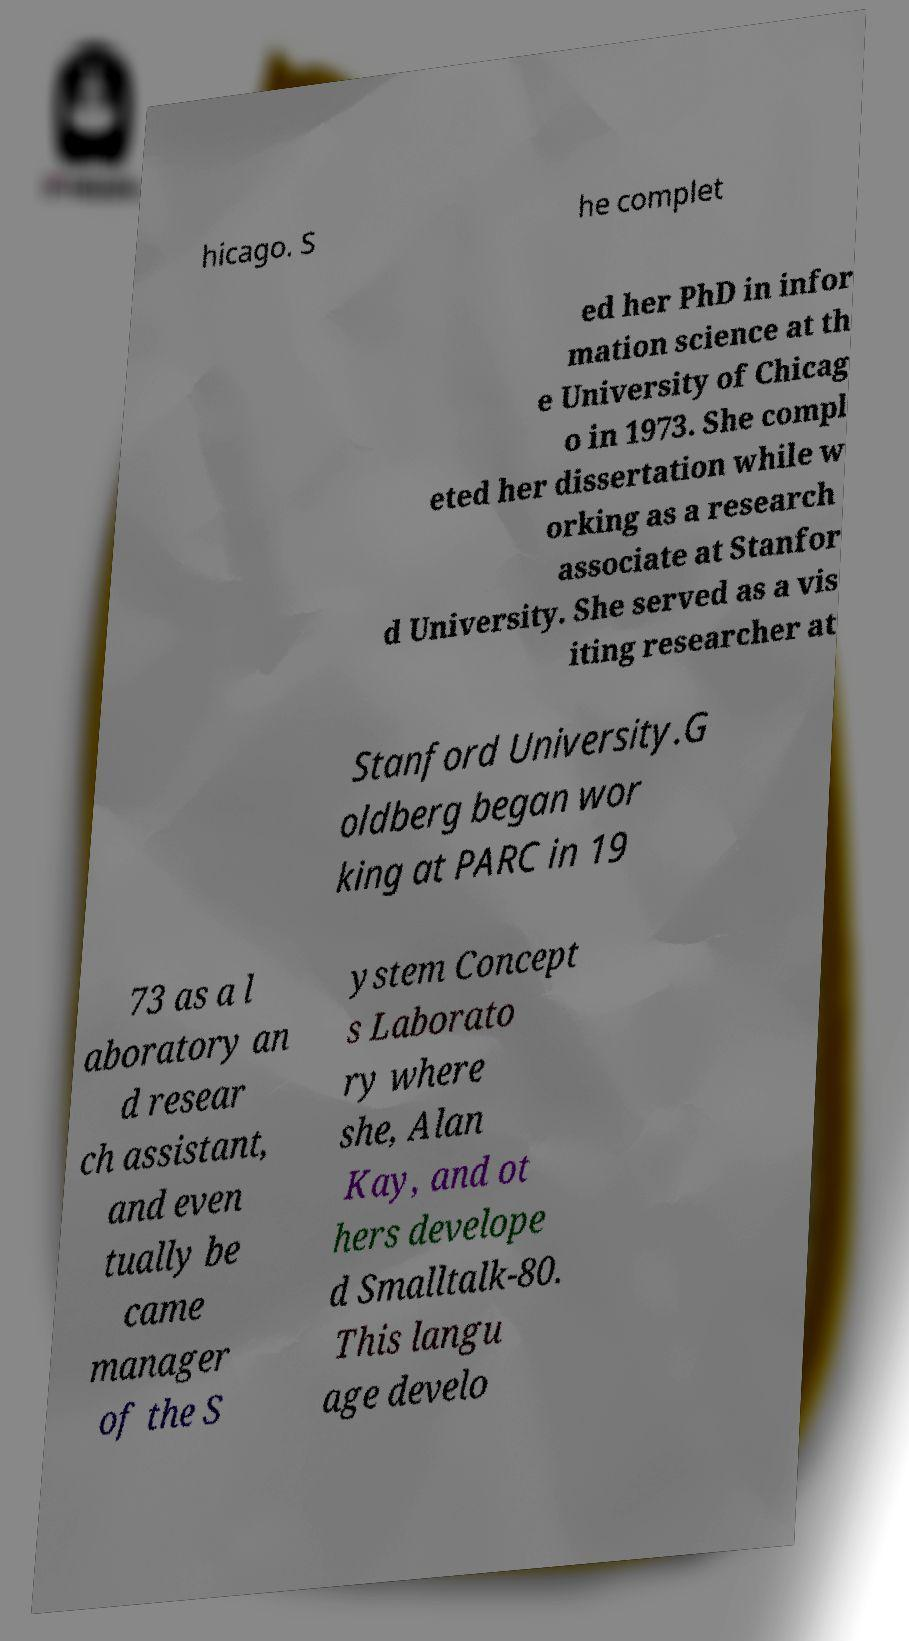What messages or text are displayed in this image? I need them in a readable, typed format. hicago. S he complet ed her PhD in infor mation science at th e University of Chicag o in 1973. She compl eted her dissertation while w orking as a research associate at Stanfor d University. She served as a vis iting researcher at Stanford University.G oldberg began wor king at PARC in 19 73 as a l aboratory an d resear ch assistant, and even tually be came manager of the S ystem Concept s Laborato ry where she, Alan Kay, and ot hers develope d Smalltalk-80. This langu age develo 